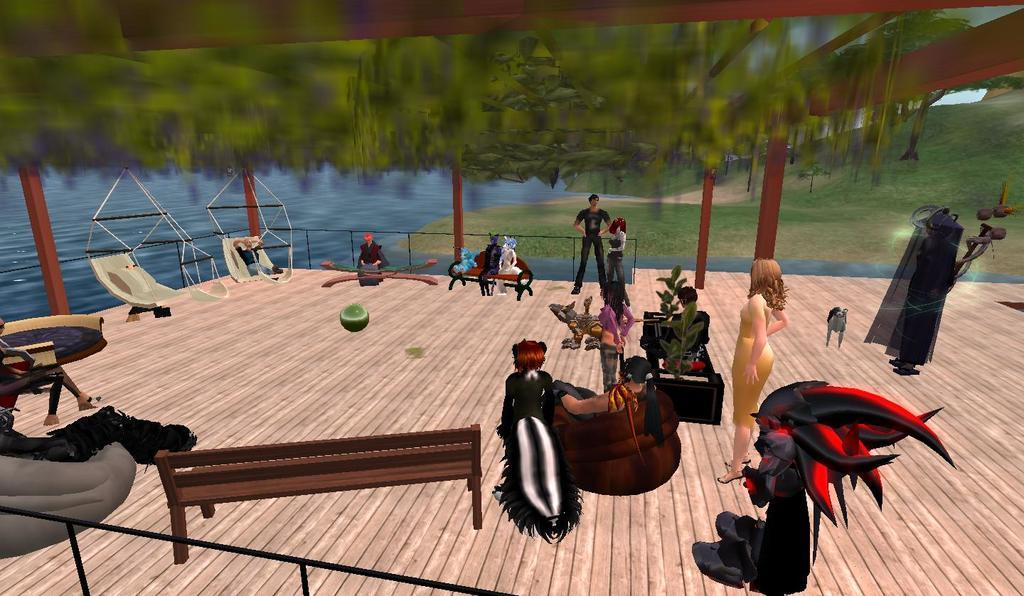What types of characters are present in the image? The image contains people, some of whom appear to be monsters. What can be seen in the background of the image? There is greenery and water visible in the background of the image. What type of stone is being used to make the cream in the image? There is no stone or cream present in the image; it features people and monsters with a background of greenery and water. 